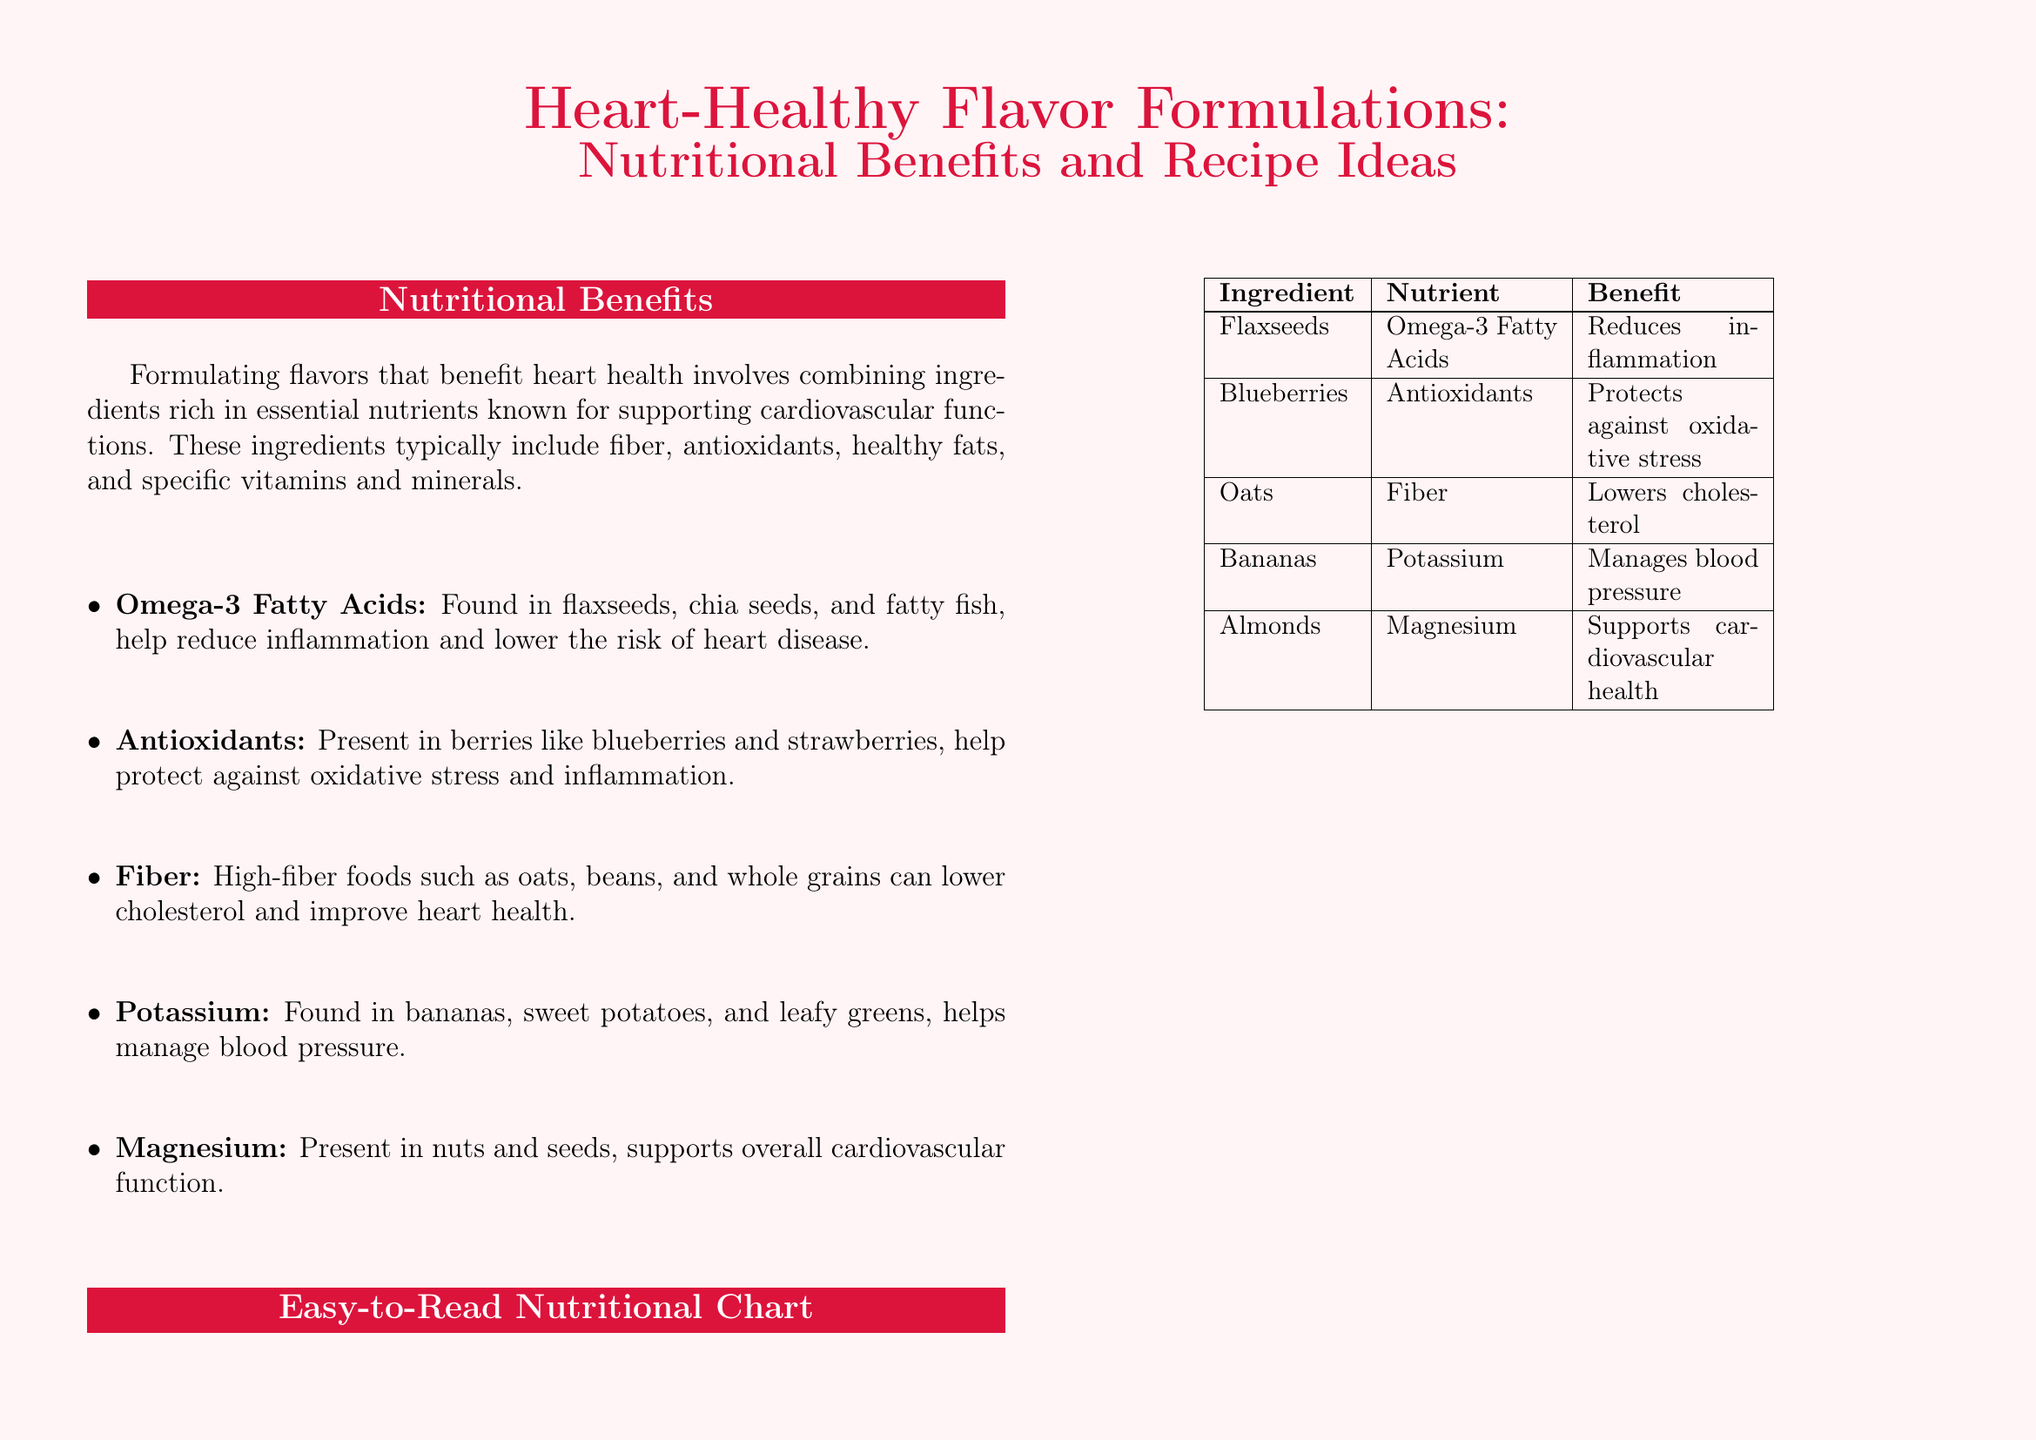What are Omega-3 Fatty Acids found in? Omega-3 Fatty Acids are found in flaxseeds, chia seeds, and fatty fish according to the document.
Answer: flaxseeds, chia seeds, and fatty fish What benefit do blueberries provide? According to the nutritional chart, blueberries provide antioxidants that protect against oxidative stress.
Answer: Protects against oxidative stress How many tablespoons of flaxseeds are used in the Berry Oatmeal recipe? The Berry Oatmeal recipe specifies 1 tablespoon of flaxseeds.
Answer: 1 tablespoon What mineral is found in bananas? The document mentions that bananas contain potassium.
Answer: Potassium What is a key ingredient in Chia Seed Pudding? The key ingredient in Chia Seed Pudding is chia seeds, as stated in the ingredients list.
Answer: chia seeds What is the total number of sample recipes provided? The flyer includes two sample recipes, namely Berry Oatmeal and Chia Seed Pudding.
Answer: 2 What should be limited to maintain heart health? The document advises limiting saturated fats and trans fats.
Answer: Saturated fats and trans fats Which nutrient helps manage blood pressure? According to the document, potassium helps manage blood pressure.
Answer: Potassium What type of milk is used in the Chia Seed Pudding recipe? The recipe for Chia Seed Pudding uses almond milk as an ingredient.
Answer: almond milk 